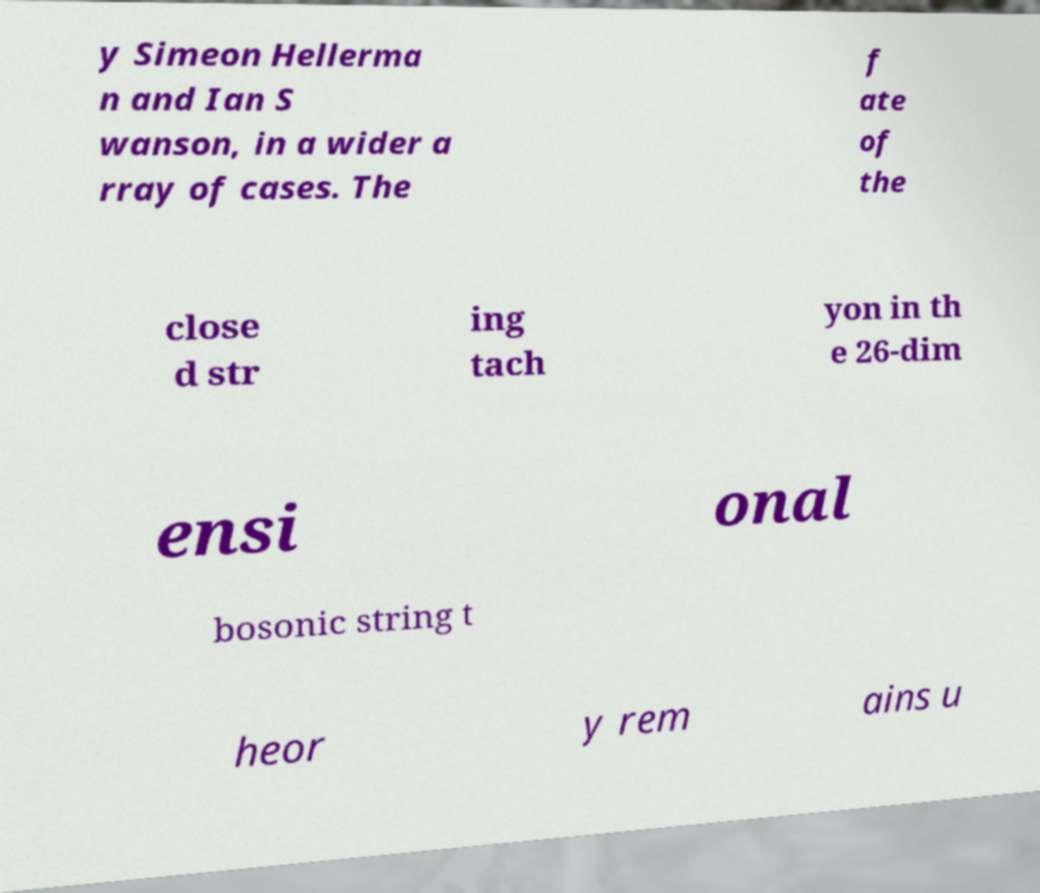There's text embedded in this image that I need extracted. Can you transcribe it verbatim? y Simeon Hellerma n and Ian S wanson, in a wider a rray of cases. The f ate of the close d str ing tach yon in th e 26-dim ensi onal bosonic string t heor y rem ains u 